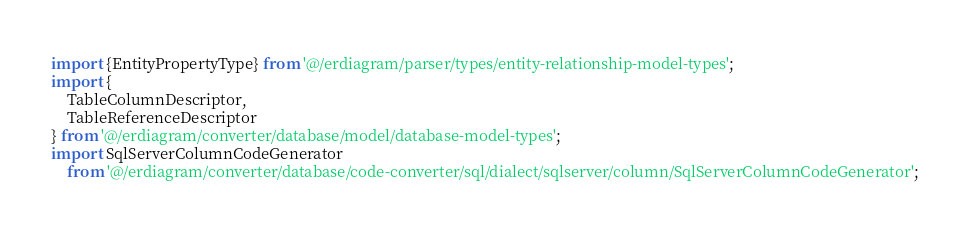Convert code to text. <code><loc_0><loc_0><loc_500><loc_500><_TypeScript_>import {EntityPropertyType} from '@/erdiagram/parser/types/entity-relationship-model-types';
import {
	TableColumnDescriptor,
	TableReferenceDescriptor
} from '@/erdiagram/converter/database/model/database-model-types';
import SqlServerColumnCodeGenerator
	from '@/erdiagram/converter/database/code-converter/sql/dialect/sqlserver/column/SqlServerColumnCodeGenerator';</code> 